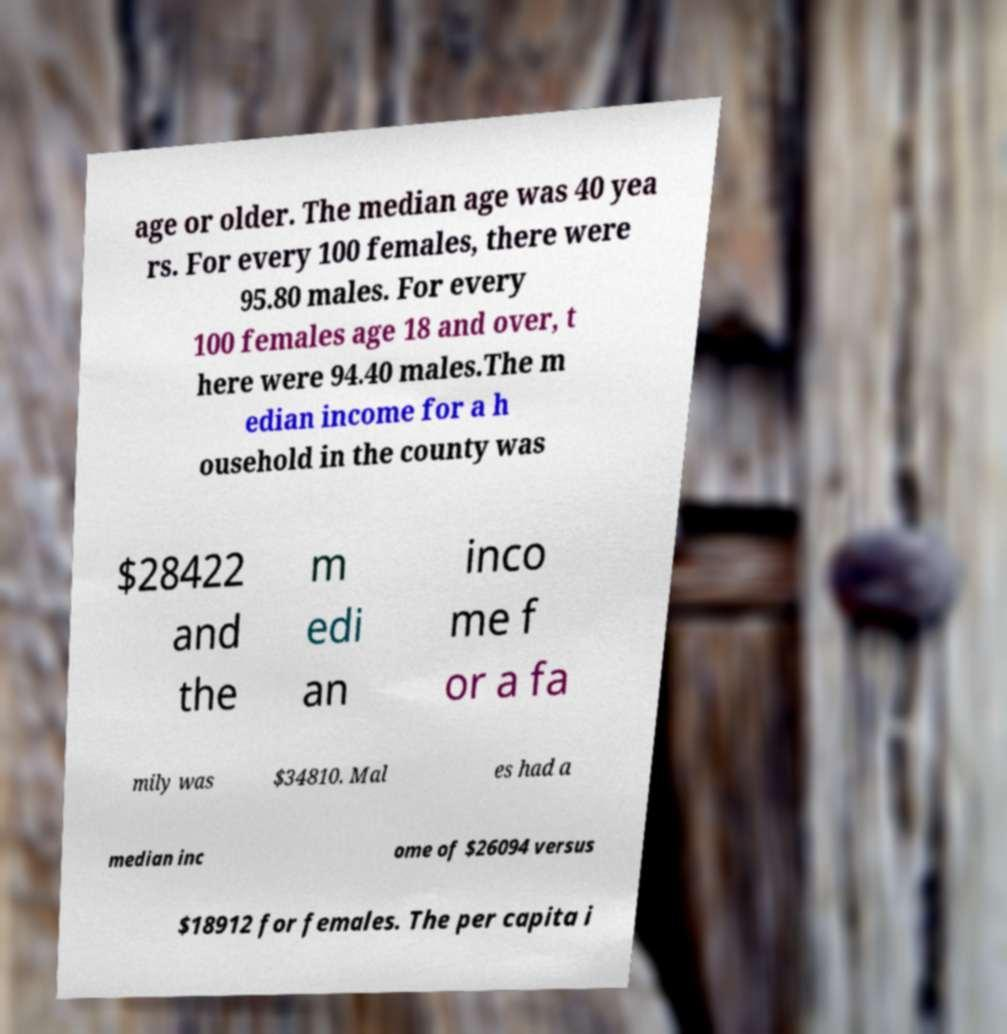Could you assist in decoding the text presented in this image and type it out clearly? age or older. The median age was 40 yea rs. For every 100 females, there were 95.80 males. For every 100 females age 18 and over, t here were 94.40 males.The m edian income for a h ousehold in the county was $28422 and the m edi an inco me f or a fa mily was $34810. Mal es had a median inc ome of $26094 versus $18912 for females. The per capita i 